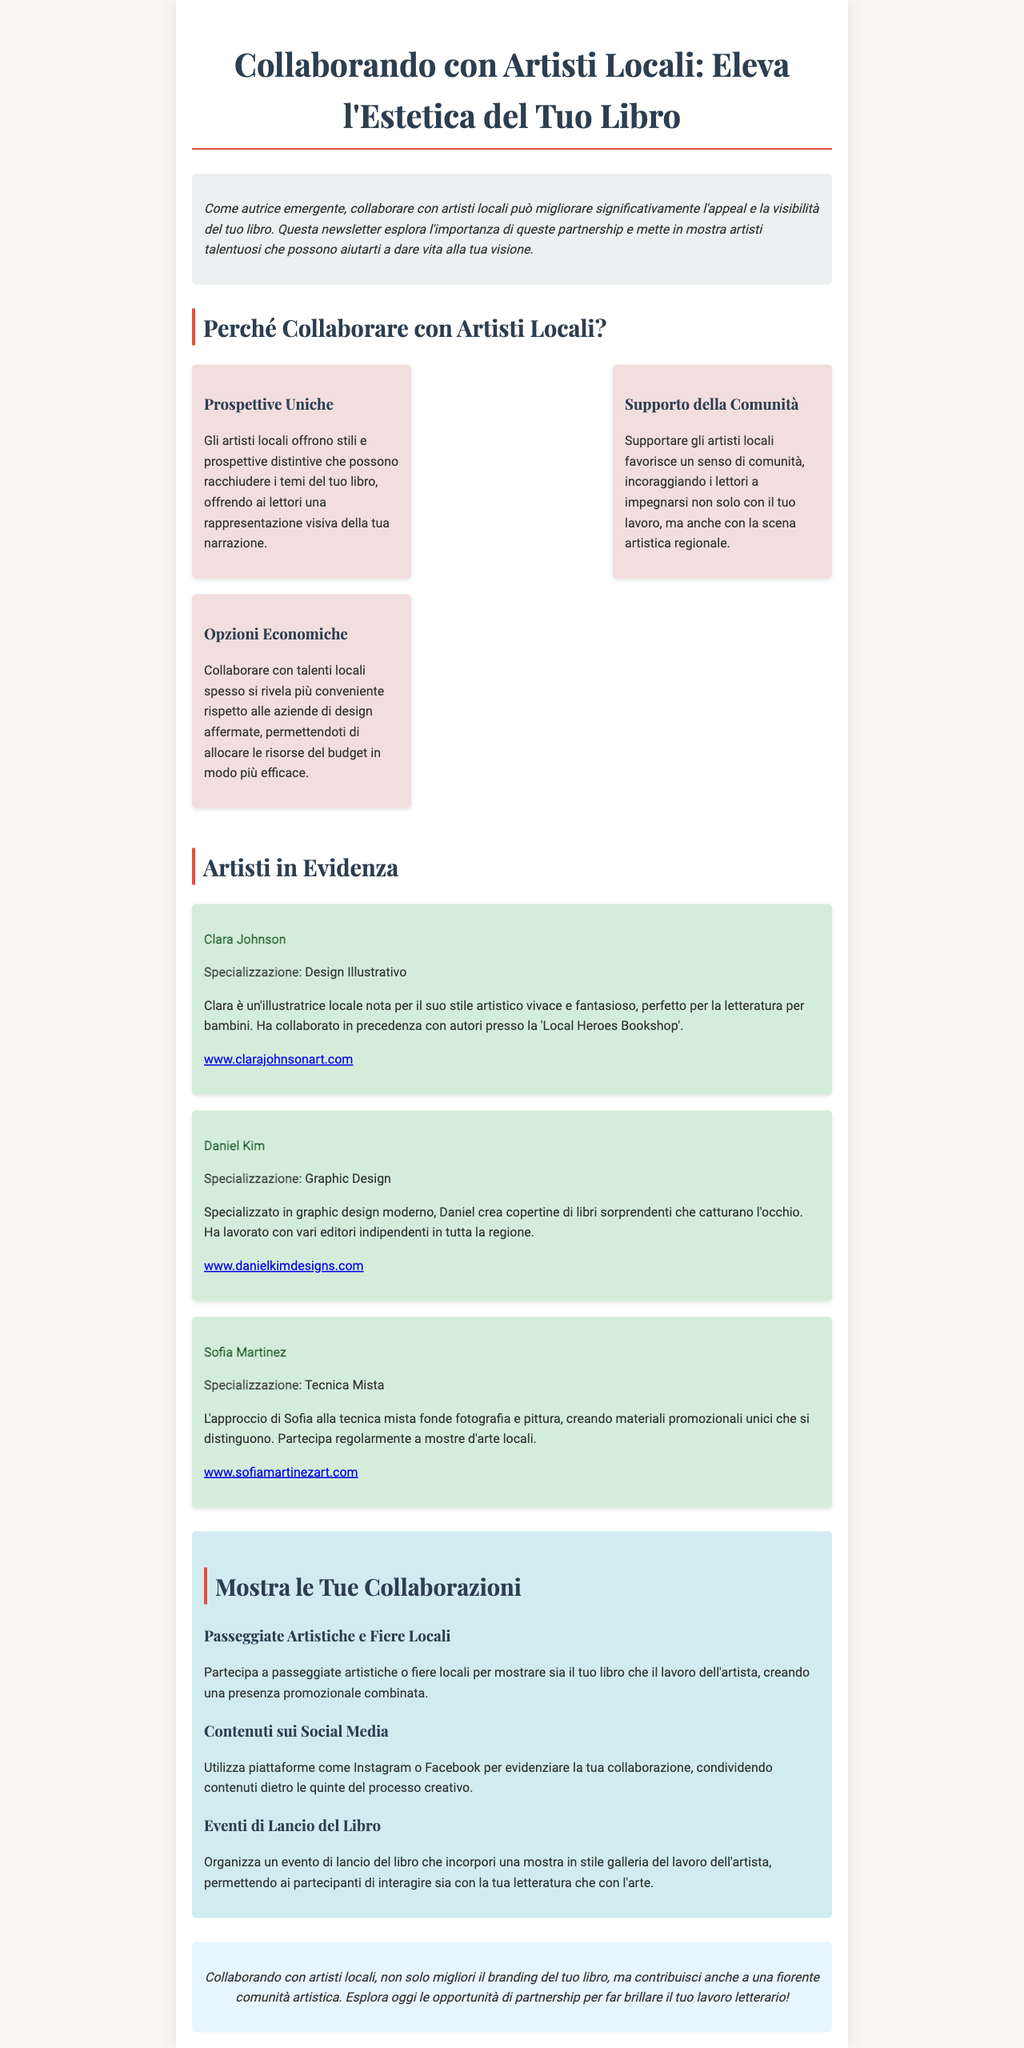Qual è il titolo della newsletter? Il titolo della newsletter è "Collaborando con Artisti Locali: Eleva l'Estetica del Tuo Libro".
Answer: Collaborando con Artisti Locali: Eleva l'Estetica del Tuo Libro Chi è Clara Johnson? Clara Johnson è un'illustratrice locale nota per il suo stile artistico vivace e fantasioso.
Answer: Clara Johnson Qual è la specializzazione di Daniel Kim? Daniel Kim è specializzato in graphic design moderno.
Answer: Graphic Design Quali sono le opportunità di mostra prevista nel documento? Le opportunità di mostra includono Passeggiate Artistiche e Fiere Locali, Contenuti sui Social Media, e Eventi di Lancio del Libro.
Answer: Passeggiate Artistiche e Fiere Locali, Contenuti sui Social Media, Eventi di Lancio del Libro Perché è importante supportare artisti locali? Supportare artisti locali favorisce un senso di comunità.
Answer: Senso di comunità Qual è uno dei vantaggi economici di collaborare con artisti locali? Collaborare con talenti locali spesso si rivela più conveniente.
Answer: Più conveniente Qual è la tecnica usata da Sofia Martinez? Sofia Martinez utilizza una tecnica mista che fonde fotografia e pittura.
Answer: Tecnica mista Cosa si intende per "prospettive uniche"? Prospettive uniche si riferisce agli stili e alle visioni distintive offerti dagli artisti locali.
Answer: Stili e visioni distintive 